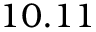Convert formula to latex. <formula><loc_0><loc_0><loc_500><loc_500>1 0 . 1 1</formula> 